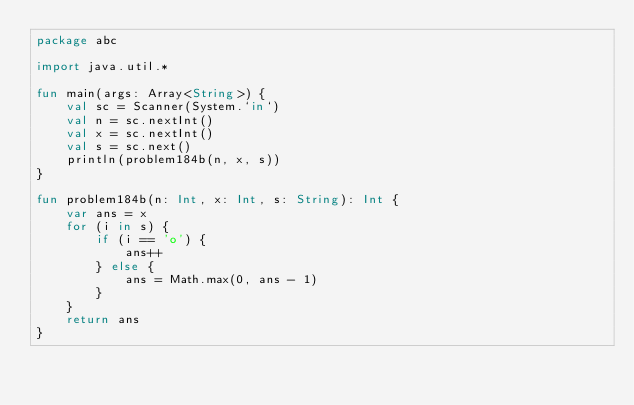<code> <loc_0><loc_0><loc_500><loc_500><_Kotlin_>package abc

import java.util.*

fun main(args: Array<String>) {
    val sc = Scanner(System.`in`)
    val n = sc.nextInt()
    val x = sc.nextInt()
    val s = sc.next()
    println(problem184b(n, x, s))
}

fun problem184b(n: Int, x: Int, s: String): Int {
    var ans = x
    for (i in s) {
        if (i == 'o') {
            ans++
        } else {
            ans = Math.max(0, ans - 1)
        }
    }
    return ans
}</code> 